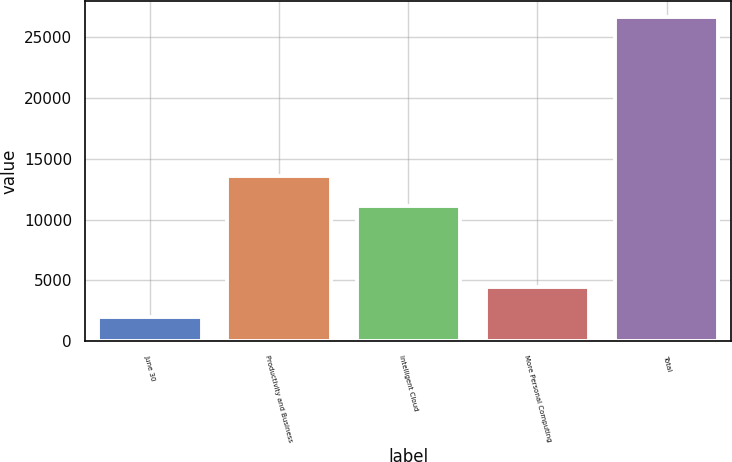<chart> <loc_0><loc_0><loc_500><loc_500><bar_chart><fcel>June 30<fcel>Productivity and Business<fcel>Intelligent Cloud<fcel>More Personal Computing<fcel>Total<nl><fcel>2017<fcel>13615.9<fcel>11152<fcel>4480.9<fcel>26656<nl></chart> 